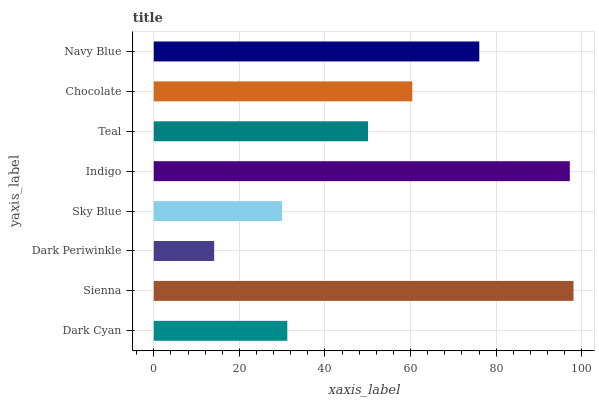Is Dark Periwinkle the minimum?
Answer yes or no. Yes. Is Sienna the maximum?
Answer yes or no. Yes. Is Sienna the minimum?
Answer yes or no. No. Is Dark Periwinkle the maximum?
Answer yes or no. No. Is Sienna greater than Dark Periwinkle?
Answer yes or no. Yes. Is Dark Periwinkle less than Sienna?
Answer yes or no. Yes. Is Dark Periwinkle greater than Sienna?
Answer yes or no. No. Is Sienna less than Dark Periwinkle?
Answer yes or no. No. Is Chocolate the high median?
Answer yes or no. Yes. Is Teal the low median?
Answer yes or no. Yes. Is Sienna the high median?
Answer yes or no. No. Is Chocolate the low median?
Answer yes or no. No. 